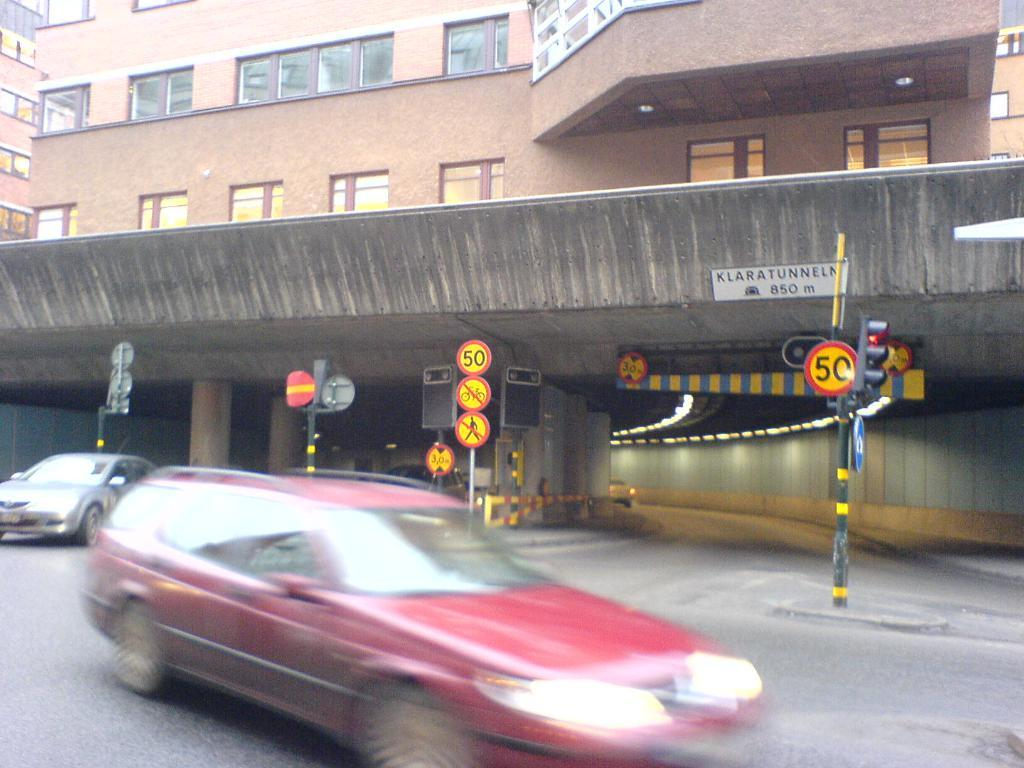Provide a one-sentence caption for the provided image. A blurred red car on a street with a 50 sign in the background. 